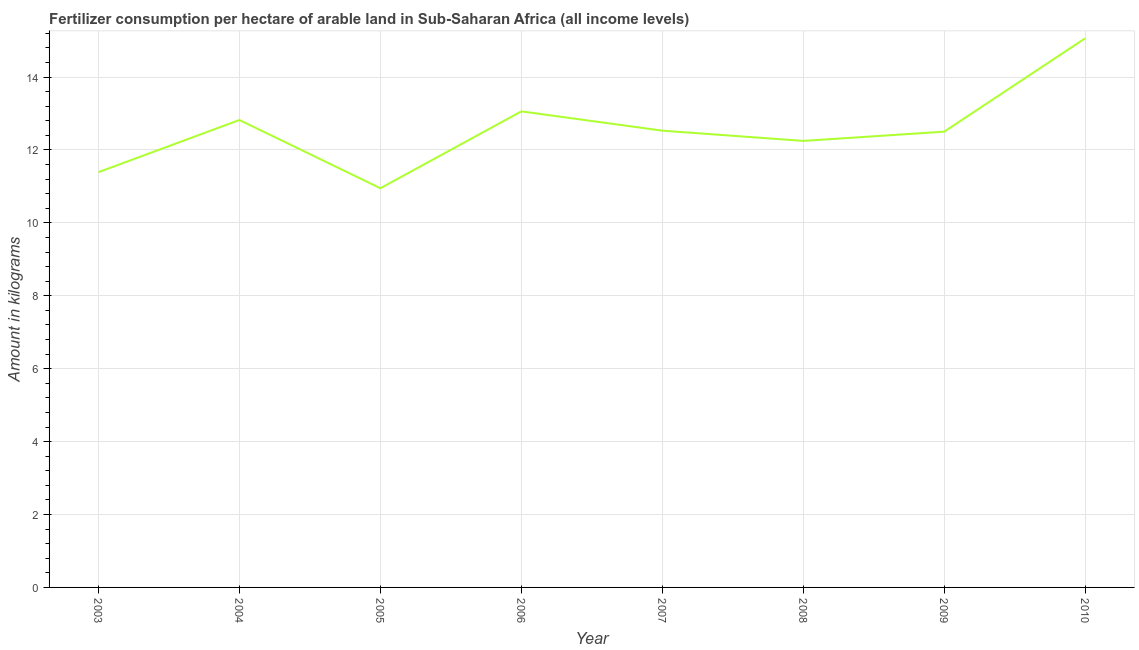What is the amount of fertilizer consumption in 2005?
Give a very brief answer. 10.95. Across all years, what is the maximum amount of fertilizer consumption?
Your answer should be compact. 15.06. Across all years, what is the minimum amount of fertilizer consumption?
Your response must be concise. 10.95. In which year was the amount of fertilizer consumption maximum?
Your answer should be very brief. 2010. What is the sum of the amount of fertilizer consumption?
Ensure brevity in your answer.  100.55. What is the difference between the amount of fertilizer consumption in 2005 and 2010?
Keep it short and to the point. -4.11. What is the average amount of fertilizer consumption per year?
Give a very brief answer. 12.57. What is the median amount of fertilizer consumption?
Give a very brief answer. 12.51. In how many years, is the amount of fertilizer consumption greater than 14.8 kg?
Provide a short and direct response. 1. Do a majority of the years between 2004 and 2005 (inclusive) have amount of fertilizer consumption greater than 10.4 kg?
Make the answer very short. Yes. What is the ratio of the amount of fertilizer consumption in 2005 to that in 2010?
Your response must be concise. 0.73. What is the difference between the highest and the second highest amount of fertilizer consumption?
Provide a succinct answer. 2. Is the sum of the amount of fertilizer consumption in 2006 and 2010 greater than the maximum amount of fertilizer consumption across all years?
Ensure brevity in your answer.  Yes. What is the difference between the highest and the lowest amount of fertilizer consumption?
Provide a short and direct response. 4.11. In how many years, is the amount of fertilizer consumption greater than the average amount of fertilizer consumption taken over all years?
Offer a terse response. 3. Does the amount of fertilizer consumption monotonically increase over the years?
Your answer should be compact. No. How many years are there in the graph?
Offer a very short reply. 8. Are the values on the major ticks of Y-axis written in scientific E-notation?
Provide a short and direct response. No. Does the graph contain any zero values?
Provide a short and direct response. No. What is the title of the graph?
Keep it short and to the point. Fertilizer consumption per hectare of arable land in Sub-Saharan Africa (all income levels) . What is the label or title of the X-axis?
Provide a succinct answer. Year. What is the label or title of the Y-axis?
Your answer should be compact. Amount in kilograms. What is the Amount in kilograms of 2003?
Offer a terse response. 11.39. What is the Amount in kilograms in 2004?
Ensure brevity in your answer.  12.82. What is the Amount in kilograms of 2005?
Offer a very short reply. 10.95. What is the Amount in kilograms of 2006?
Provide a succinct answer. 13.06. What is the Amount in kilograms in 2007?
Give a very brief answer. 12.53. What is the Amount in kilograms in 2008?
Your answer should be compact. 12.25. What is the Amount in kilograms in 2009?
Your answer should be compact. 12.5. What is the Amount in kilograms in 2010?
Offer a very short reply. 15.06. What is the difference between the Amount in kilograms in 2003 and 2004?
Make the answer very short. -1.43. What is the difference between the Amount in kilograms in 2003 and 2005?
Provide a short and direct response. 0.44. What is the difference between the Amount in kilograms in 2003 and 2006?
Make the answer very short. -1.67. What is the difference between the Amount in kilograms in 2003 and 2007?
Offer a very short reply. -1.14. What is the difference between the Amount in kilograms in 2003 and 2008?
Offer a terse response. -0.86. What is the difference between the Amount in kilograms in 2003 and 2009?
Your answer should be very brief. -1.11. What is the difference between the Amount in kilograms in 2003 and 2010?
Keep it short and to the point. -3.67. What is the difference between the Amount in kilograms in 2004 and 2005?
Your answer should be very brief. 1.87. What is the difference between the Amount in kilograms in 2004 and 2006?
Your answer should be very brief. -0.24. What is the difference between the Amount in kilograms in 2004 and 2007?
Ensure brevity in your answer.  0.29. What is the difference between the Amount in kilograms in 2004 and 2008?
Provide a short and direct response. 0.57. What is the difference between the Amount in kilograms in 2004 and 2009?
Your answer should be compact. 0.32. What is the difference between the Amount in kilograms in 2004 and 2010?
Keep it short and to the point. -2.24. What is the difference between the Amount in kilograms in 2005 and 2006?
Give a very brief answer. -2.11. What is the difference between the Amount in kilograms in 2005 and 2007?
Keep it short and to the point. -1.58. What is the difference between the Amount in kilograms in 2005 and 2008?
Your answer should be very brief. -1.3. What is the difference between the Amount in kilograms in 2005 and 2009?
Make the answer very short. -1.55. What is the difference between the Amount in kilograms in 2005 and 2010?
Give a very brief answer. -4.11. What is the difference between the Amount in kilograms in 2006 and 2007?
Give a very brief answer. 0.53. What is the difference between the Amount in kilograms in 2006 and 2008?
Offer a terse response. 0.81. What is the difference between the Amount in kilograms in 2006 and 2009?
Your answer should be very brief. 0.56. What is the difference between the Amount in kilograms in 2006 and 2010?
Provide a short and direct response. -2. What is the difference between the Amount in kilograms in 2007 and 2008?
Make the answer very short. 0.28. What is the difference between the Amount in kilograms in 2007 and 2009?
Provide a succinct answer. 0.03. What is the difference between the Amount in kilograms in 2007 and 2010?
Provide a short and direct response. -2.53. What is the difference between the Amount in kilograms in 2008 and 2009?
Your answer should be very brief. -0.25. What is the difference between the Amount in kilograms in 2008 and 2010?
Ensure brevity in your answer.  -2.81. What is the difference between the Amount in kilograms in 2009 and 2010?
Give a very brief answer. -2.56. What is the ratio of the Amount in kilograms in 2003 to that in 2004?
Offer a very short reply. 0.89. What is the ratio of the Amount in kilograms in 2003 to that in 2006?
Provide a short and direct response. 0.87. What is the ratio of the Amount in kilograms in 2003 to that in 2007?
Provide a short and direct response. 0.91. What is the ratio of the Amount in kilograms in 2003 to that in 2009?
Your answer should be very brief. 0.91. What is the ratio of the Amount in kilograms in 2003 to that in 2010?
Your answer should be compact. 0.76. What is the ratio of the Amount in kilograms in 2004 to that in 2005?
Ensure brevity in your answer.  1.17. What is the ratio of the Amount in kilograms in 2004 to that in 2006?
Give a very brief answer. 0.98. What is the ratio of the Amount in kilograms in 2004 to that in 2007?
Give a very brief answer. 1.02. What is the ratio of the Amount in kilograms in 2004 to that in 2008?
Provide a short and direct response. 1.05. What is the ratio of the Amount in kilograms in 2004 to that in 2009?
Provide a succinct answer. 1.03. What is the ratio of the Amount in kilograms in 2004 to that in 2010?
Make the answer very short. 0.85. What is the ratio of the Amount in kilograms in 2005 to that in 2006?
Give a very brief answer. 0.84. What is the ratio of the Amount in kilograms in 2005 to that in 2007?
Make the answer very short. 0.87. What is the ratio of the Amount in kilograms in 2005 to that in 2008?
Ensure brevity in your answer.  0.89. What is the ratio of the Amount in kilograms in 2005 to that in 2009?
Your answer should be very brief. 0.88. What is the ratio of the Amount in kilograms in 2005 to that in 2010?
Ensure brevity in your answer.  0.73. What is the ratio of the Amount in kilograms in 2006 to that in 2007?
Provide a succinct answer. 1.04. What is the ratio of the Amount in kilograms in 2006 to that in 2008?
Your answer should be very brief. 1.07. What is the ratio of the Amount in kilograms in 2006 to that in 2009?
Ensure brevity in your answer.  1.04. What is the ratio of the Amount in kilograms in 2006 to that in 2010?
Keep it short and to the point. 0.87. What is the ratio of the Amount in kilograms in 2007 to that in 2009?
Ensure brevity in your answer.  1. What is the ratio of the Amount in kilograms in 2007 to that in 2010?
Offer a terse response. 0.83. What is the ratio of the Amount in kilograms in 2008 to that in 2010?
Keep it short and to the point. 0.81. What is the ratio of the Amount in kilograms in 2009 to that in 2010?
Your answer should be very brief. 0.83. 